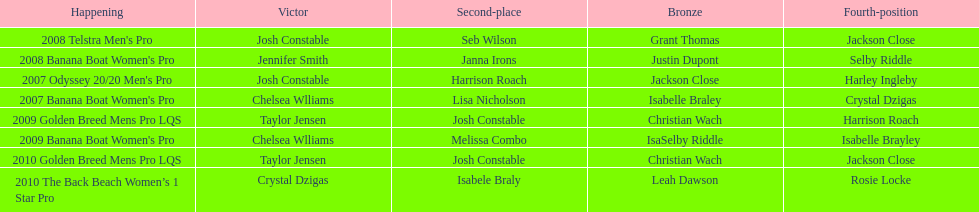In which years did taylor jensen emerge as the winner? 2009, 2010. 